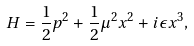Convert formula to latex. <formula><loc_0><loc_0><loc_500><loc_500>H = \frac { 1 } { 2 } p ^ { 2 } + \frac { 1 } { 2 } \mu ^ { 2 } x ^ { 2 } + i \epsilon x ^ { 3 } ,</formula> 